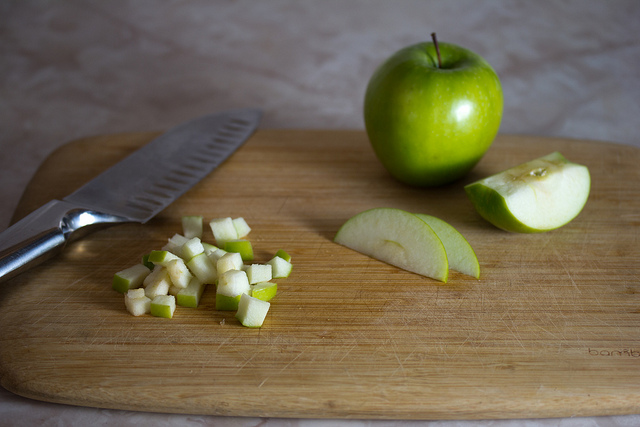What is the primary object on the cutting board? The primary objects on the cutting board are apples, displayed in different cuts such as whole apples, sliced segments, and finely diced pieces, showing the various ways apples can be prepared for different culinary uses. 